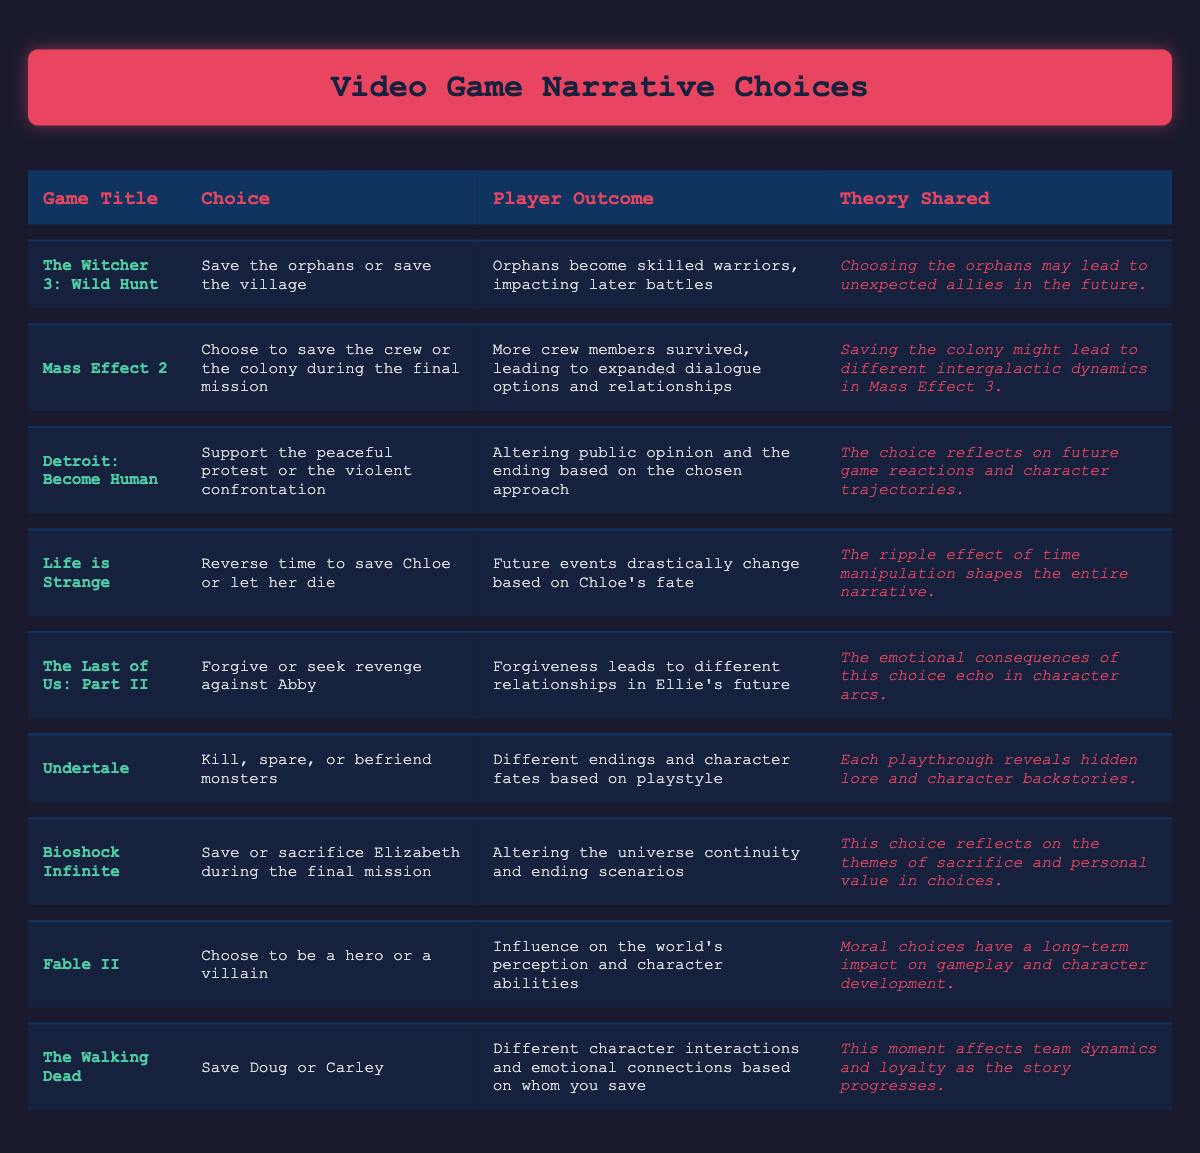What choice does "The Witcher 3: Wild Hunt" present to players? The table lists the choice in the row for "The Witcher 3: Wild Hunt" as "Save the orphans or save the village."
Answer: Save the orphans or save the village What is the outcome for "Life is Strange" if the player lets Chloe die? According to the table, if Chloe dies, future events drastically change based on her fate.
Answer: Future events drastically change Is there any choice in the table that deals with forgiveness? The table indicates that "The Last of Us: Part II" has a choice of "Forgive or seek revenge against Abby," which relates to forgiveness.
Answer: Yes Which game has an outcome that leads to different endings based on playstyle? By checking the table, "Undertale" has an outcome described as "Different endings and character fates based on playstyle."
Answer: Undertale What are the two choices available in "Mass Effect 2"? Referring to the table, the choices listed are "Choose to save the crew or the colony during the final mission."
Answer: Save the crew or the colony For which game does choosing the peaceful approach alter public opinion? The table shows that "Detroit: Become Human" deals with supporting "the peaceful protest or the violent confrontation," which affects public opinion.
Answer: Detroit: Become Human How does the choice of saving Doug or Carley in "The Walking Dead" affect player experience? The table states that this choice leads to different character interactions and emotional connections based on whom the player saves.
Answer: Different character interactions Which game's narrative choice talks about the concept of sacrifice? The table mentions "Bioshock Infinite" involves saving or sacrificing Elizabeth during the final mission, reflecting themes of sacrifice.
Answer: Bioshock Infinite What relationship does the choice of forgiving Abby affect in "The Last of Us: Part II"? The table specifies that forgiveness leads to different relationships in Ellie's future as a result of the choice.
Answer: Different relationships in Ellie's future If you wanted to analyze the games based on player outcomes influenced by moral choices, which two games could be compared and why? "Fable II" and "The Last of Us: Part II" both involve moral choices with long-term impacts, as "Fable II" influences the world’s perception and character abilities, while "The Last of Us: Part II" affects Ellie’s relationships.
Answer: Fable II and The Last of Us: Part II 